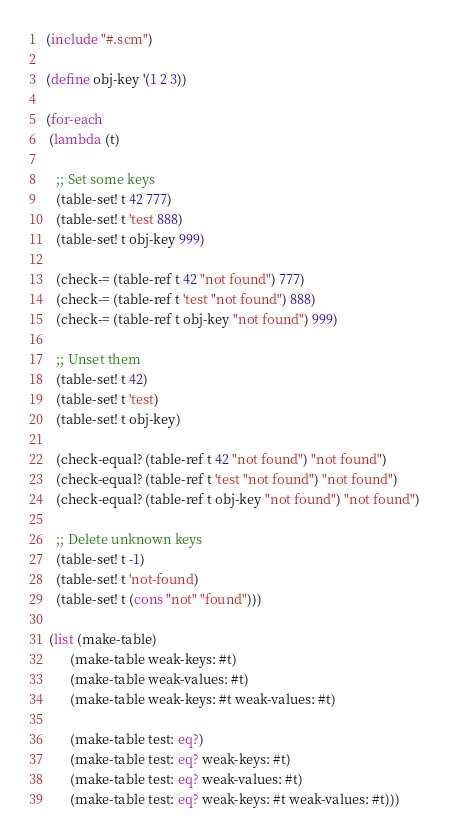Convert code to text. <code><loc_0><loc_0><loc_500><loc_500><_Scheme_>(include "#.scm")

(define obj-key '(1 2 3))

(for-each
 (lambda (t)

   ;; Set some keys
   (table-set! t 42 777)
   (table-set! t 'test 888)
   (table-set! t obj-key 999)

   (check-= (table-ref t 42 "not found") 777)
   (check-= (table-ref t 'test "not found") 888)
   (check-= (table-ref t obj-key "not found") 999)

   ;; Unset them
   (table-set! t 42)
   (table-set! t 'test)
   (table-set! t obj-key)

   (check-equal? (table-ref t 42 "not found") "not found")
   (check-equal? (table-ref t 'test "not found") "not found")
   (check-equal? (table-ref t obj-key "not found") "not found")

   ;; Delete unknown keys
   (table-set! t -1)
   (table-set! t 'not-found)
   (table-set! t (cons "not" "found")))

 (list (make-table)
       (make-table weak-keys: #t)
       (make-table weak-values: #t)
       (make-table weak-keys: #t weak-values: #t)

       (make-table test: eq?)
       (make-table test: eq? weak-keys: #t)
       (make-table test: eq? weak-values: #t)
       (make-table test: eq? weak-keys: #t weak-values: #t)))

</code> 